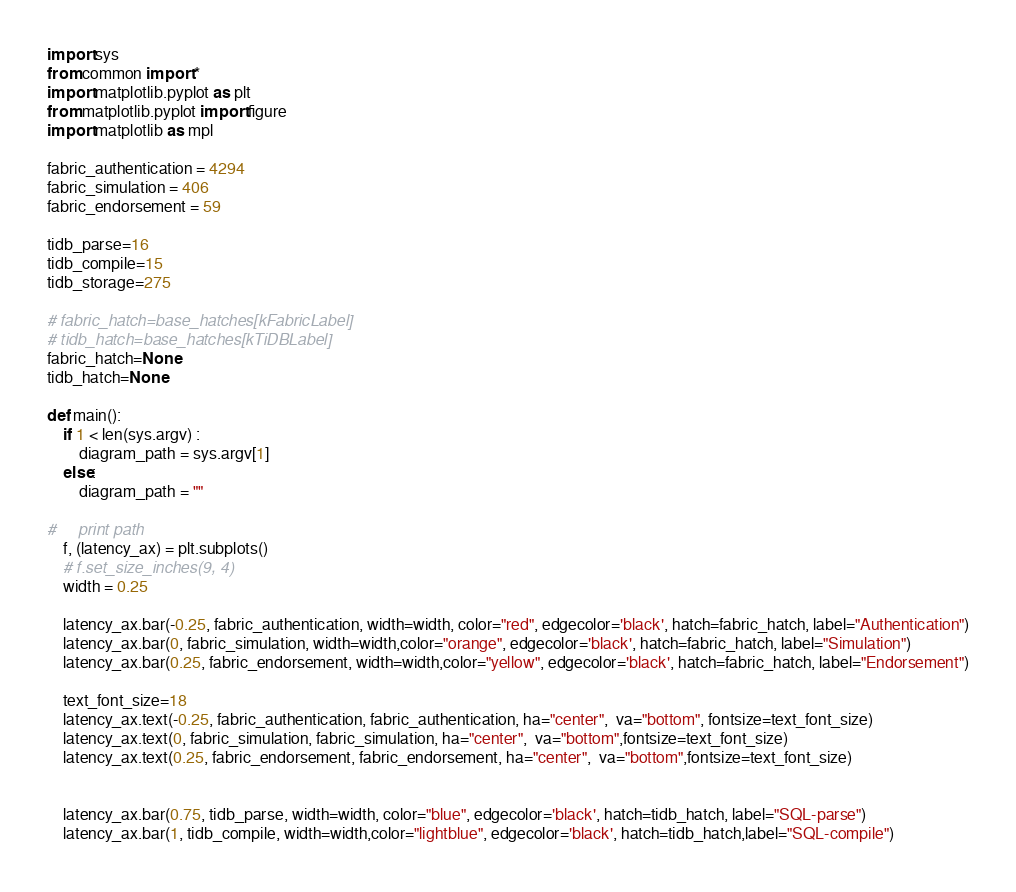<code> <loc_0><loc_0><loc_500><loc_500><_Python_>import sys
from common import *
import matplotlib.pyplot as plt
from matplotlib.pyplot import figure
import matplotlib as mpl

fabric_authentication = 4294
fabric_simulation = 406
fabric_endorsement = 59

tidb_parse=16
tidb_compile=15
tidb_storage=275

# fabric_hatch=base_hatches[kFabricLabel]
# tidb_hatch=base_hatches[kTiDBLabel]
fabric_hatch=None
tidb_hatch=None

def main():
    if 1 < len(sys.argv) :
        diagram_path = sys.argv[1]
    else:
        diagram_path = ""
    
#     print path
    f, (latency_ax) = plt.subplots()
    # f.set_size_inches(9, 4)
    width = 0.25

    latency_ax.bar(-0.25, fabric_authentication, width=width, color="red", edgecolor='black', hatch=fabric_hatch, label="Authentication")
    latency_ax.bar(0, fabric_simulation, width=width,color="orange", edgecolor='black', hatch=fabric_hatch, label="Simulation")
    latency_ax.bar(0.25, fabric_endorsement, width=width,color="yellow", edgecolor='black', hatch=fabric_hatch, label="Endorsement")

    text_font_size=18
    latency_ax.text(-0.25, fabric_authentication, fabric_authentication, ha="center",  va="bottom", fontsize=text_font_size)
    latency_ax.text(0, fabric_simulation, fabric_simulation, ha="center",  va="bottom",fontsize=text_font_size)
    latency_ax.text(0.25, fabric_endorsement, fabric_endorsement, ha="center",  va="bottom",fontsize=text_font_size)


    latency_ax.bar(0.75, tidb_parse, width=width, color="blue", edgecolor='black', hatch=tidb_hatch, label="SQL-parse")
    latency_ax.bar(1, tidb_compile, width=width,color="lightblue", edgecolor='black', hatch=tidb_hatch,label="SQL-compile")</code> 